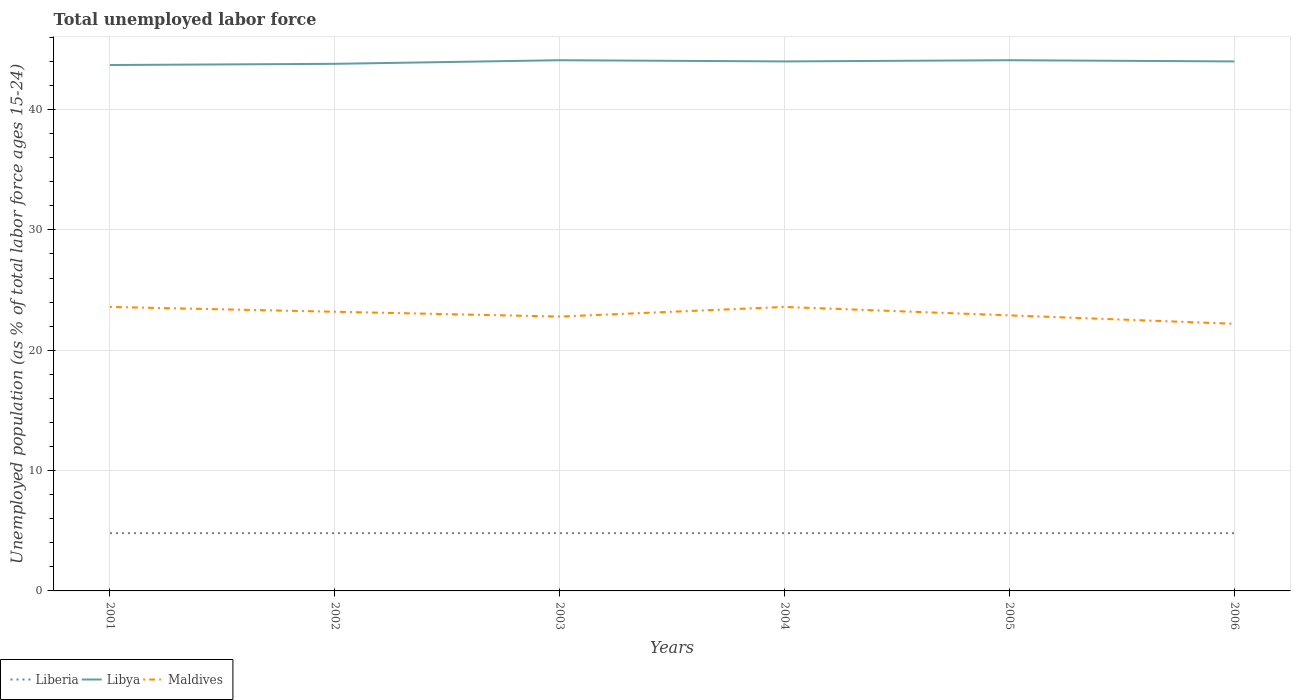Does the line corresponding to Liberia intersect with the line corresponding to Libya?
Your answer should be compact. No. Is the number of lines equal to the number of legend labels?
Provide a short and direct response. Yes. Across all years, what is the maximum percentage of unemployed population in in Maldives?
Provide a succinct answer. 22.2. In which year was the percentage of unemployed population in in Libya maximum?
Ensure brevity in your answer.  2001. What is the difference between the highest and the second highest percentage of unemployed population in in Maldives?
Ensure brevity in your answer.  1.4. What is the difference between the highest and the lowest percentage of unemployed population in in Libya?
Ensure brevity in your answer.  4. How many years are there in the graph?
Ensure brevity in your answer.  6. What is the difference between two consecutive major ticks on the Y-axis?
Offer a terse response. 10. Where does the legend appear in the graph?
Provide a short and direct response. Bottom left. How many legend labels are there?
Offer a terse response. 3. What is the title of the graph?
Your answer should be very brief. Total unemployed labor force. Does "France" appear as one of the legend labels in the graph?
Your response must be concise. No. What is the label or title of the Y-axis?
Make the answer very short. Unemployed population (as % of total labor force ages 15-24). What is the Unemployed population (as % of total labor force ages 15-24) of Liberia in 2001?
Your response must be concise. 4.8. What is the Unemployed population (as % of total labor force ages 15-24) in Libya in 2001?
Offer a terse response. 43.7. What is the Unemployed population (as % of total labor force ages 15-24) of Maldives in 2001?
Make the answer very short. 23.6. What is the Unemployed population (as % of total labor force ages 15-24) of Liberia in 2002?
Offer a terse response. 4.8. What is the Unemployed population (as % of total labor force ages 15-24) in Libya in 2002?
Offer a very short reply. 43.8. What is the Unemployed population (as % of total labor force ages 15-24) of Maldives in 2002?
Make the answer very short. 23.2. What is the Unemployed population (as % of total labor force ages 15-24) in Liberia in 2003?
Offer a very short reply. 4.8. What is the Unemployed population (as % of total labor force ages 15-24) of Libya in 2003?
Offer a terse response. 44.1. What is the Unemployed population (as % of total labor force ages 15-24) of Maldives in 2003?
Offer a terse response. 22.8. What is the Unemployed population (as % of total labor force ages 15-24) of Liberia in 2004?
Offer a very short reply. 4.8. What is the Unemployed population (as % of total labor force ages 15-24) of Libya in 2004?
Your answer should be compact. 44. What is the Unemployed population (as % of total labor force ages 15-24) of Maldives in 2004?
Your answer should be very brief. 23.6. What is the Unemployed population (as % of total labor force ages 15-24) in Liberia in 2005?
Your answer should be very brief. 4.8. What is the Unemployed population (as % of total labor force ages 15-24) in Libya in 2005?
Offer a terse response. 44.1. What is the Unemployed population (as % of total labor force ages 15-24) in Maldives in 2005?
Make the answer very short. 22.9. What is the Unemployed population (as % of total labor force ages 15-24) of Liberia in 2006?
Provide a succinct answer. 4.8. What is the Unemployed population (as % of total labor force ages 15-24) of Maldives in 2006?
Provide a succinct answer. 22.2. Across all years, what is the maximum Unemployed population (as % of total labor force ages 15-24) of Liberia?
Your answer should be very brief. 4.8. Across all years, what is the maximum Unemployed population (as % of total labor force ages 15-24) in Libya?
Your answer should be compact. 44.1. Across all years, what is the maximum Unemployed population (as % of total labor force ages 15-24) of Maldives?
Your response must be concise. 23.6. Across all years, what is the minimum Unemployed population (as % of total labor force ages 15-24) in Liberia?
Offer a very short reply. 4.8. Across all years, what is the minimum Unemployed population (as % of total labor force ages 15-24) in Libya?
Your answer should be very brief. 43.7. Across all years, what is the minimum Unemployed population (as % of total labor force ages 15-24) of Maldives?
Provide a short and direct response. 22.2. What is the total Unemployed population (as % of total labor force ages 15-24) of Liberia in the graph?
Your response must be concise. 28.8. What is the total Unemployed population (as % of total labor force ages 15-24) in Libya in the graph?
Keep it short and to the point. 263.7. What is the total Unemployed population (as % of total labor force ages 15-24) of Maldives in the graph?
Keep it short and to the point. 138.3. What is the difference between the Unemployed population (as % of total labor force ages 15-24) of Libya in 2001 and that in 2004?
Offer a terse response. -0.3. What is the difference between the Unemployed population (as % of total labor force ages 15-24) in Maldives in 2001 and that in 2004?
Provide a short and direct response. 0. What is the difference between the Unemployed population (as % of total labor force ages 15-24) of Libya in 2001 and that in 2005?
Make the answer very short. -0.4. What is the difference between the Unemployed population (as % of total labor force ages 15-24) in Maldives in 2001 and that in 2006?
Your answer should be very brief. 1.4. What is the difference between the Unemployed population (as % of total labor force ages 15-24) of Liberia in 2002 and that in 2004?
Offer a terse response. 0. What is the difference between the Unemployed population (as % of total labor force ages 15-24) of Libya in 2002 and that in 2004?
Offer a terse response. -0.2. What is the difference between the Unemployed population (as % of total labor force ages 15-24) of Liberia in 2002 and that in 2005?
Provide a short and direct response. 0. What is the difference between the Unemployed population (as % of total labor force ages 15-24) in Maldives in 2002 and that in 2005?
Ensure brevity in your answer.  0.3. What is the difference between the Unemployed population (as % of total labor force ages 15-24) in Libya in 2003 and that in 2004?
Offer a terse response. 0.1. What is the difference between the Unemployed population (as % of total labor force ages 15-24) of Maldives in 2003 and that in 2004?
Your answer should be very brief. -0.8. What is the difference between the Unemployed population (as % of total labor force ages 15-24) of Liberia in 2003 and that in 2005?
Your answer should be compact. 0. What is the difference between the Unemployed population (as % of total labor force ages 15-24) in Maldives in 2003 and that in 2005?
Offer a very short reply. -0.1. What is the difference between the Unemployed population (as % of total labor force ages 15-24) of Maldives in 2003 and that in 2006?
Keep it short and to the point. 0.6. What is the difference between the Unemployed population (as % of total labor force ages 15-24) in Liberia in 2004 and that in 2005?
Offer a terse response. 0. What is the difference between the Unemployed population (as % of total labor force ages 15-24) of Libya in 2004 and that in 2005?
Make the answer very short. -0.1. What is the difference between the Unemployed population (as % of total labor force ages 15-24) in Liberia in 2004 and that in 2006?
Offer a very short reply. 0. What is the difference between the Unemployed population (as % of total labor force ages 15-24) in Libya in 2004 and that in 2006?
Give a very brief answer. 0. What is the difference between the Unemployed population (as % of total labor force ages 15-24) of Maldives in 2004 and that in 2006?
Your response must be concise. 1.4. What is the difference between the Unemployed population (as % of total labor force ages 15-24) in Liberia in 2005 and that in 2006?
Provide a short and direct response. 0. What is the difference between the Unemployed population (as % of total labor force ages 15-24) in Liberia in 2001 and the Unemployed population (as % of total labor force ages 15-24) in Libya in 2002?
Provide a succinct answer. -39. What is the difference between the Unemployed population (as % of total labor force ages 15-24) in Liberia in 2001 and the Unemployed population (as % of total labor force ages 15-24) in Maldives in 2002?
Provide a short and direct response. -18.4. What is the difference between the Unemployed population (as % of total labor force ages 15-24) of Libya in 2001 and the Unemployed population (as % of total labor force ages 15-24) of Maldives in 2002?
Your answer should be compact. 20.5. What is the difference between the Unemployed population (as % of total labor force ages 15-24) of Liberia in 2001 and the Unemployed population (as % of total labor force ages 15-24) of Libya in 2003?
Ensure brevity in your answer.  -39.3. What is the difference between the Unemployed population (as % of total labor force ages 15-24) of Libya in 2001 and the Unemployed population (as % of total labor force ages 15-24) of Maldives in 2003?
Make the answer very short. 20.9. What is the difference between the Unemployed population (as % of total labor force ages 15-24) in Liberia in 2001 and the Unemployed population (as % of total labor force ages 15-24) in Libya in 2004?
Offer a very short reply. -39.2. What is the difference between the Unemployed population (as % of total labor force ages 15-24) in Liberia in 2001 and the Unemployed population (as % of total labor force ages 15-24) in Maldives in 2004?
Offer a very short reply. -18.8. What is the difference between the Unemployed population (as % of total labor force ages 15-24) in Libya in 2001 and the Unemployed population (as % of total labor force ages 15-24) in Maldives in 2004?
Your response must be concise. 20.1. What is the difference between the Unemployed population (as % of total labor force ages 15-24) of Liberia in 2001 and the Unemployed population (as % of total labor force ages 15-24) of Libya in 2005?
Your answer should be very brief. -39.3. What is the difference between the Unemployed population (as % of total labor force ages 15-24) of Liberia in 2001 and the Unemployed population (as % of total labor force ages 15-24) of Maldives in 2005?
Your answer should be very brief. -18.1. What is the difference between the Unemployed population (as % of total labor force ages 15-24) in Libya in 2001 and the Unemployed population (as % of total labor force ages 15-24) in Maldives in 2005?
Provide a succinct answer. 20.8. What is the difference between the Unemployed population (as % of total labor force ages 15-24) in Liberia in 2001 and the Unemployed population (as % of total labor force ages 15-24) in Libya in 2006?
Keep it short and to the point. -39.2. What is the difference between the Unemployed population (as % of total labor force ages 15-24) of Liberia in 2001 and the Unemployed population (as % of total labor force ages 15-24) of Maldives in 2006?
Offer a very short reply. -17.4. What is the difference between the Unemployed population (as % of total labor force ages 15-24) in Liberia in 2002 and the Unemployed population (as % of total labor force ages 15-24) in Libya in 2003?
Your response must be concise. -39.3. What is the difference between the Unemployed population (as % of total labor force ages 15-24) of Liberia in 2002 and the Unemployed population (as % of total labor force ages 15-24) of Maldives in 2003?
Keep it short and to the point. -18. What is the difference between the Unemployed population (as % of total labor force ages 15-24) in Liberia in 2002 and the Unemployed population (as % of total labor force ages 15-24) in Libya in 2004?
Give a very brief answer. -39.2. What is the difference between the Unemployed population (as % of total labor force ages 15-24) in Liberia in 2002 and the Unemployed population (as % of total labor force ages 15-24) in Maldives in 2004?
Make the answer very short. -18.8. What is the difference between the Unemployed population (as % of total labor force ages 15-24) of Libya in 2002 and the Unemployed population (as % of total labor force ages 15-24) of Maldives in 2004?
Make the answer very short. 20.2. What is the difference between the Unemployed population (as % of total labor force ages 15-24) in Liberia in 2002 and the Unemployed population (as % of total labor force ages 15-24) in Libya in 2005?
Your answer should be compact. -39.3. What is the difference between the Unemployed population (as % of total labor force ages 15-24) of Liberia in 2002 and the Unemployed population (as % of total labor force ages 15-24) of Maldives in 2005?
Your answer should be compact. -18.1. What is the difference between the Unemployed population (as % of total labor force ages 15-24) of Libya in 2002 and the Unemployed population (as % of total labor force ages 15-24) of Maldives in 2005?
Provide a short and direct response. 20.9. What is the difference between the Unemployed population (as % of total labor force ages 15-24) of Liberia in 2002 and the Unemployed population (as % of total labor force ages 15-24) of Libya in 2006?
Offer a very short reply. -39.2. What is the difference between the Unemployed population (as % of total labor force ages 15-24) of Liberia in 2002 and the Unemployed population (as % of total labor force ages 15-24) of Maldives in 2006?
Keep it short and to the point. -17.4. What is the difference between the Unemployed population (as % of total labor force ages 15-24) in Libya in 2002 and the Unemployed population (as % of total labor force ages 15-24) in Maldives in 2006?
Ensure brevity in your answer.  21.6. What is the difference between the Unemployed population (as % of total labor force ages 15-24) in Liberia in 2003 and the Unemployed population (as % of total labor force ages 15-24) in Libya in 2004?
Give a very brief answer. -39.2. What is the difference between the Unemployed population (as % of total labor force ages 15-24) of Liberia in 2003 and the Unemployed population (as % of total labor force ages 15-24) of Maldives in 2004?
Keep it short and to the point. -18.8. What is the difference between the Unemployed population (as % of total labor force ages 15-24) of Liberia in 2003 and the Unemployed population (as % of total labor force ages 15-24) of Libya in 2005?
Provide a short and direct response. -39.3. What is the difference between the Unemployed population (as % of total labor force ages 15-24) of Liberia in 2003 and the Unemployed population (as % of total labor force ages 15-24) of Maldives in 2005?
Your answer should be compact. -18.1. What is the difference between the Unemployed population (as % of total labor force ages 15-24) in Libya in 2003 and the Unemployed population (as % of total labor force ages 15-24) in Maldives in 2005?
Give a very brief answer. 21.2. What is the difference between the Unemployed population (as % of total labor force ages 15-24) of Liberia in 2003 and the Unemployed population (as % of total labor force ages 15-24) of Libya in 2006?
Provide a succinct answer. -39.2. What is the difference between the Unemployed population (as % of total labor force ages 15-24) in Liberia in 2003 and the Unemployed population (as % of total labor force ages 15-24) in Maldives in 2006?
Ensure brevity in your answer.  -17.4. What is the difference between the Unemployed population (as % of total labor force ages 15-24) in Libya in 2003 and the Unemployed population (as % of total labor force ages 15-24) in Maldives in 2006?
Provide a succinct answer. 21.9. What is the difference between the Unemployed population (as % of total labor force ages 15-24) in Liberia in 2004 and the Unemployed population (as % of total labor force ages 15-24) in Libya in 2005?
Provide a short and direct response. -39.3. What is the difference between the Unemployed population (as % of total labor force ages 15-24) of Liberia in 2004 and the Unemployed population (as % of total labor force ages 15-24) of Maldives in 2005?
Your response must be concise. -18.1. What is the difference between the Unemployed population (as % of total labor force ages 15-24) in Libya in 2004 and the Unemployed population (as % of total labor force ages 15-24) in Maldives in 2005?
Make the answer very short. 21.1. What is the difference between the Unemployed population (as % of total labor force ages 15-24) of Liberia in 2004 and the Unemployed population (as % of total labor force ages 15-24) of Libya in 2006?
Your answer should be very brief. -39.2. What is the difference between the Unemployed population (as % of total labor force ages 15-24) of Liberia in 2004 and the Unemployed population (as % of total labor force ages 15-24) of Maldives in 2006?
Your response must be concise. -17.4. What is the difference between the Unemployed population (as % of total labor force ages 15-24) in Libya in 2004 and the Unemployed population (as % of total labor force ages 15-24) in Maldives in 2006?
Your response must be concise. 21.8. What is the difference between the Unemployed population (as % of total labor force ages 15-24) in Liberia in 2005 and the Unemployed population (as % of total labor force ages 15-24) in Libya in 2006?
Your answer should be very brief. -39.2. What is the difference between the Unemployed population (as % of total labor force ages 15-24) in Liberia in 2005 and the Unemployed population (as % of total labor force ages 15-24) in Maldives in 2006?
Offer a terse response. -17.4. What is the difference between the Unemployed population (as % of total labor force ages 15-24) in Libya in 2005 and the Unemployed population (as % of total labor force ages 15-24) in Maldives in 2006?
Keep it short and to the point. 21.9. What is the average Unemployed population (as % of total labor force ages 15-24) in Liberia per year?
Make the answer very short. 4.8. What is the average Unemployed population (as % of total labor force ages 15-24) of Libya per year?
Provide a succinct answer. 43.95. What is the average Unemployed population (as % of total labor force ages 15-24) in Maldives per year?
Keep it short and to the point. 23.05. In the year 2001, what is the difference between the Unemployed population (as % of total labor force ages 15-24) of Liberia and Unemployed population (as % of total labor force ages 15-24) of Libya?
Ensure brevity in your answer.  -38.9. In the year 2001, what is the difference between the Unemployed population (as % of total labor force ages 15-24) of Liberia and Unemployed population (as % of total labor force ages 15-24) of Maldives?
Offer a very short reply. -18.8. In the year 2001, what is the difference between the Unemployed population (as % of total labor force ages 15-24) in Libya and Unemployed population (as % of total labor force ages 15-24) in Maldives?
Keep it short and to the point. 20.1. In the year 2002, what is the difference between the Unemployed population (as % of total labor force ages 15-24) in Liberia and Unemployed population (as % of total labor force ages 15-24) in Libya?
Your answer should be very brief. -39. In the year 2002, what is the difference between the Unemployed population (as % of total labor force ages 15-24) in Liberia and Unemployed population (as % of total labor force ages 15-24) in Maldives?
Provide a succinct answer. -18.4. In the year 2002, what is the difference between the Unemployed population (as % of total labor force ages 15-24) in Libya and Unemployed population (as % of total labor force ages 15-24) in Maldives?
Make the answer very short. 20.6. In the year 2003, what is the difference between the Unemployed population (as % of total labor force ages 15-24) of Liberia and Unemployed population (as % of total labor force ages 15-24) of Libya?
Make the answer very short. -39.3. In the year 2003, what is the difference between the Unemployed population (as % of total labor force ages 15-24) of Libya and Unemployed population (as % of total labor force ages 15-24) of Maldives?
Ensure brevity in your answer.  21.3. In the year 2004, what is the difference between the Unemployed population (as % of total labor force ages 15-24) of Liberia and Unemployed population (as % of total labor force ages 15-24) of Libya?
Give a very brief answer. -39.2. In the year 2004, what is the difference between the Unemployed population (as % of total labor force ages 15-24) of Liberia and Unemployed population (as % of total labor force ages 15-24) of Maldives?
Make the answer very short. -18.8. In the year 2004, what is the difference between the Unemployed population (as % of total labor force ages 15-24) of Libya and Unemployed population (as % of total labor force ages 15-24) of Maldives?
Make the answer very short. 20.4. In the year 2005, what is the difference between the Unemployed population (as % of total labor force ages 15-24) in Liberia and Unemployed population (as % of total labor force ages 15-24) in Libya?
Keep it short and to the point. -39.3. In the year 2005, what is the difference between the Unemployed population (as % of total labor force ages 15-24) in Liberia and Unemployed population (as % of total labor force ages 15-24) in Maldives?
Provide a short and direct response. -18.1. In the year 2005, what is the difference between the Unemployed population (as % of total labor force ages 15-24) in Libya and Unemployed population (as % of total labor force ages 15-24) in Maldives?
Your response must be concise. 21.2. In the year 2006, what is the difference between the Unemployed population (as % of total labor force ages 15-24) of Liberia and Unemployed population (as % of total labor force ages 15-24) of Libya?
Provide a succinct answer. -39.2. In the year 2006, what is the difference between the Unemployed population (as % of total labor force ages 15-24) in Liberia and Unemployed population (as % of total labor force ages 15-24) in Maldives?
Keep it short and to the point. -17.4. In the year 2006, what is the difference between the Unemployed population (as % of total labor force ages 15-24) in Libya and Unemployed population (as % of total labor force ages 15-24) in Maldives?
Give a very brief answer. 21.8. What is the ratio of the Unemployed population (as % of total labor force ages 15-24) in Libya in 2001 to that in 2002?
Make the answer very short. 1. What is the ratio of the Unemployed population (as % of total labor force ages 15-24) in Maldives in 2001 to that in 2002?
Ensure brevity in your answer.  1.02. What is the ratio of the Unemployed population (as % of total labor force ages 15-24) in Liberia in 2001 to that in 2003?
Offer a terse response. 1. What is the ratio of the Unemployed population (as % of total labor force ages 15-24) in Libya in 2001 to that in 2003?
Offer a very short reply. 0.99. What is the ratio of the Unemployed population (as % of total labor force ages 15-24) in Maldives in 2001 to that in 2003?
Your answer should be very brief. 1.04. What is the ratio of the Unemployed population (as % of total labor force ages 15-24) of Libya in 2001 to that in 2004?
Your answer should be compact. 0.99. What is the ratio of the Unemployed population (as % of total labor force ages 15-24) of Liberia in 2001 to that in 2005?
Offer a very short reply. 1. What is the ratio of the Unemployed population (as % of total labor force ages 15-24) in Libya in 2001 to that in 2005?
Your answer should be very brief. 0.99. What is the ratio of the Unemployed population (as % of total labor force ages 15-24) in Maldives in 2001 to that in 2005?
Ensure brevity in your answer.  1.03. What is the ratio of the Unemployed population (as % of total labor force ages 15-24) of Liberia in 2001 to that in 2006?
Your answer should be very brief. 1. What is the ratio of the Unemployed population (as % of total labor force ages 15-24) in Libya in 2001 to that in 2006?
Ensure brevity in your answer.  0.99. What is the ratio of the Unemployed population (as % of total labor force ages 15-24) in Maldives in 2001 to that in 2006?
Provide a short and direct response. 1.06. What is the ratio of the Unemployed population (as % of total labor force ages 15-24) of Maldives in 2002 to that in 2003?
Your answer should be compact. 1.02. What is the ratio of the Unemployed population (as % of total labor force ages 15-24) of Maldives in 2002 to that in 2004?
Your answer should be compact. 0.98. What is the ratio of the Unemployed population (as % of total labor force ages 15-24) in Maldives in 2002 to that in 2005?
Give a very brief answer. 1.01. What is the ratio of the Unemployed population (as % of total labor force ages 15-24) in Liberia in 2002 to that in 2006?
Your answer should be very brief. 1. What is the ratio of the Unemployed population (as % of total labor force ages 15-24) of Maldives in 2002 to that in 2006?
Your answer should be very brief. 1.04. What is the ratio of the Unemployed population (as % of total labor force ages 15-24) in Libya in 2003 to that in 2004?
Make the answer very short. 1. What is the ratio of the Unemployed population (as % of total labor force ages 15-24) in Maldives in 2003 to that in 2004?
Your answer should be very brief. 0.97. What is the ratio of the Unemployed population (as % of total labor force ages 15-24) in Liberia in 2003 to that in 2005?
Provide a short and direct response. 1. What is the ratio of the Unemployed population (as % of total labor force ages 15-24) in Liberia in 2003 to that in 2006?
Make the answer very short. 1. What is the ratio of the Unemployed population (as % of total labor force ages 15-24) in Libya in 2003 to that in 2006?
Offer a terse response. 1. What is the ratio of the Unemployed population (as % of total labor force ages 15-24) of Libya in 2004 to that in 2005?
Your response must be concise. 1. What is the ratio of the Unemployed population (as % of total labor force ages 15-24) in Maldives in 2004 to that in 2005?
Keep it short and to the point. 1.03. What is the ratio of the Unemployed population (as % of total labor force ages 15-24) in Liberia in 2004 to that in 2006?
Ensure brevity in your answer.  1. What is the ratio of the Unemployed population (as % of total labor force ages 15-24) in Maldives in 2004 to that in 2006?
Provide a succinct answer. 1.06. What is the ratio of the Unemployed population (as % of total labor force ages 15-24) in Liberia in 2005 to that in 2006?
Your response must be concise. 1. What is the ratio of the Unemployed population (as % of total labor force ages 15-24) of Libya in 2005 to that in 2006?
Provide a short and direct response. 1. What is the ratio of the Unemployed population (as % of total labor force ages 15-24) in Maldives in 2005 to that in 2006?
Your answer should be compact. 1.03. What is the difference between the highest and the second highest Unemployed population (as % of total labor force ages 15-24) of Libya?
Offer a very short reply. 0. What is the difference between the highest and the second highest Unemployed population (as % of total labor force ages 15-24) in Maldives?
Your response must be concise. 0. What is the difference between the highest and the lowest Unemployed population (as % of total labor force ages 15-24) of Liberia?
Keep it short and to the point. 0. What is the difference between the highest and the lowest Unemployed population (as % of total labor force ages 15-24) in Libya?
Ensure brevity in your answer.  0.4. What is the difference between the highest and the lowest Unemployed population (as % of total labor force ages 15-24) in Maldives?
Make the answer very short. 1.4. 